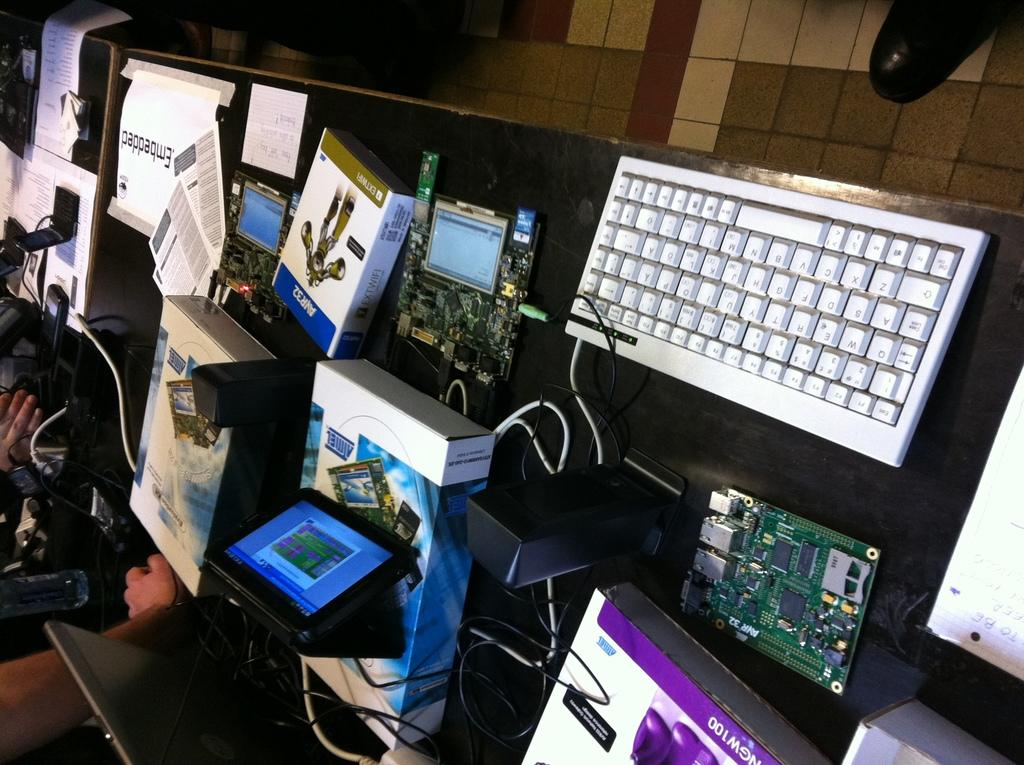Provide a one-sentence caption for the provided image. Computer parts on a table with one part named "AVR32". 